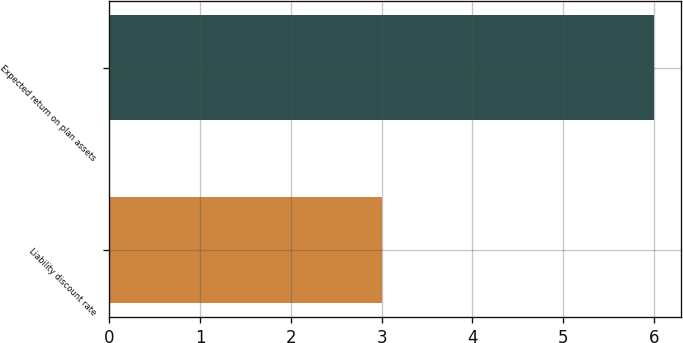Convert chart. <chart><loc_0><loc_0><loc_500><loc_500><bar_chart><fcel>Liability discount rate<fcel>Expected return on plan assets<nl><fcel>3<fcel>6<nl></chart> 